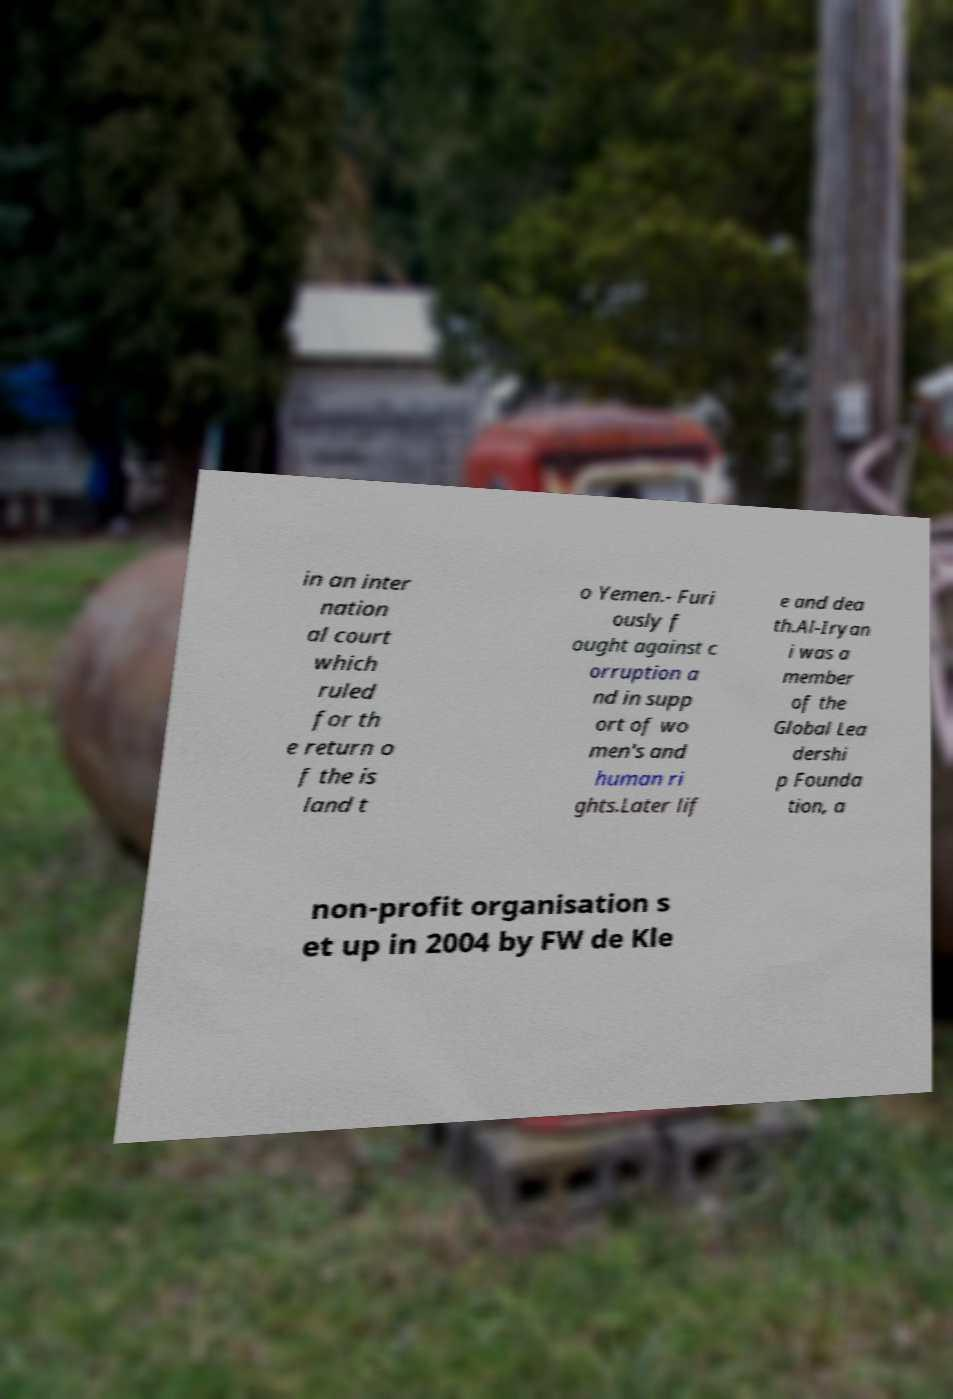What messages or text are displayed in this image? I need them in a readable, typed format. in an inter nation al court which ruled for th e return o f the is land t o Yemen.- Furi ously f ought against c orruption a nd in supp ort of wo men's and human ri ghts.Later lif e and dea th.Al-Iryan i was a member of the Global Lea dershi p Founda tion, a non-profit organisation s et up in 2004 by FW de Kle 